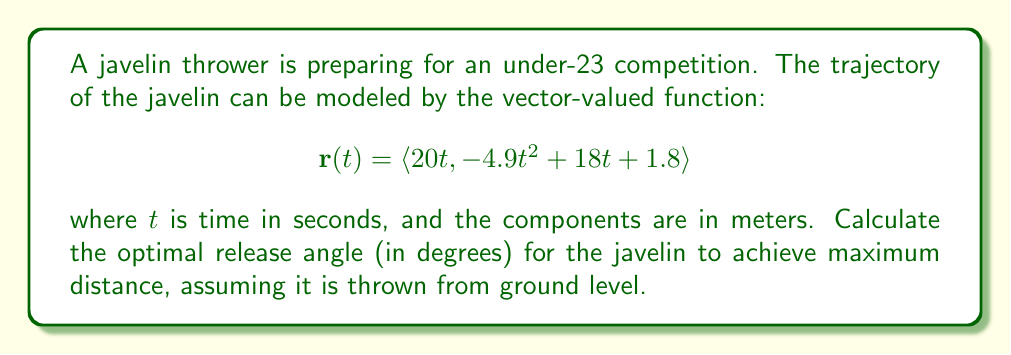Could you help me with this problem? To find the optimal release angle, we need to follow these steps:

1) First, we need to find the time when the javelin hits the ground. This occurs when the y-component of $\mathbf{r}(t)$ equals zero:

   $$-4.9t^2 + 18t + 1.8 = 0$$

2) Solve this quadratic equation:
   
   $$t = \frac{-18 \pm \sqrt{18^2 + 4(4.9)(1.8)}}{2(-4.9)} \approx 3.82 \text{ seconds}$$

   We take the positive root as it represents the time when the javelin lands.

3) The horizontal distance traveled is given by the x-component of $\mathbf{r}(t)$ at this time:

   $$x = 20t = 20(3.82) \approx 76.4 \text{ meters}$$

4) The initial velocity components are:
   
   $$v_x = 20 \text{ m/s}$$
   $$v_y = 18 \text{ m/s}$$

5) The initial velocity magnitude is:

   $$v = \sqrt{v_x^2 + v_y^2} = \sqrt{20^2 + 18^2} \approx 26.91 \text{ m/s}$$

6) The optimal release angle $\theta$ is given by:

   $$\theta = \arctan(\frac{v_y}{v_x})$$

7) Calculate the angle:

   $$\theta = \arctan(\frac{18}{20}) \approx 41.99°$$

Therefore, the optimal release angle for the javelin is approximately 42°.
Answer: The optimal release angle for the javelin is approximately 42°. 